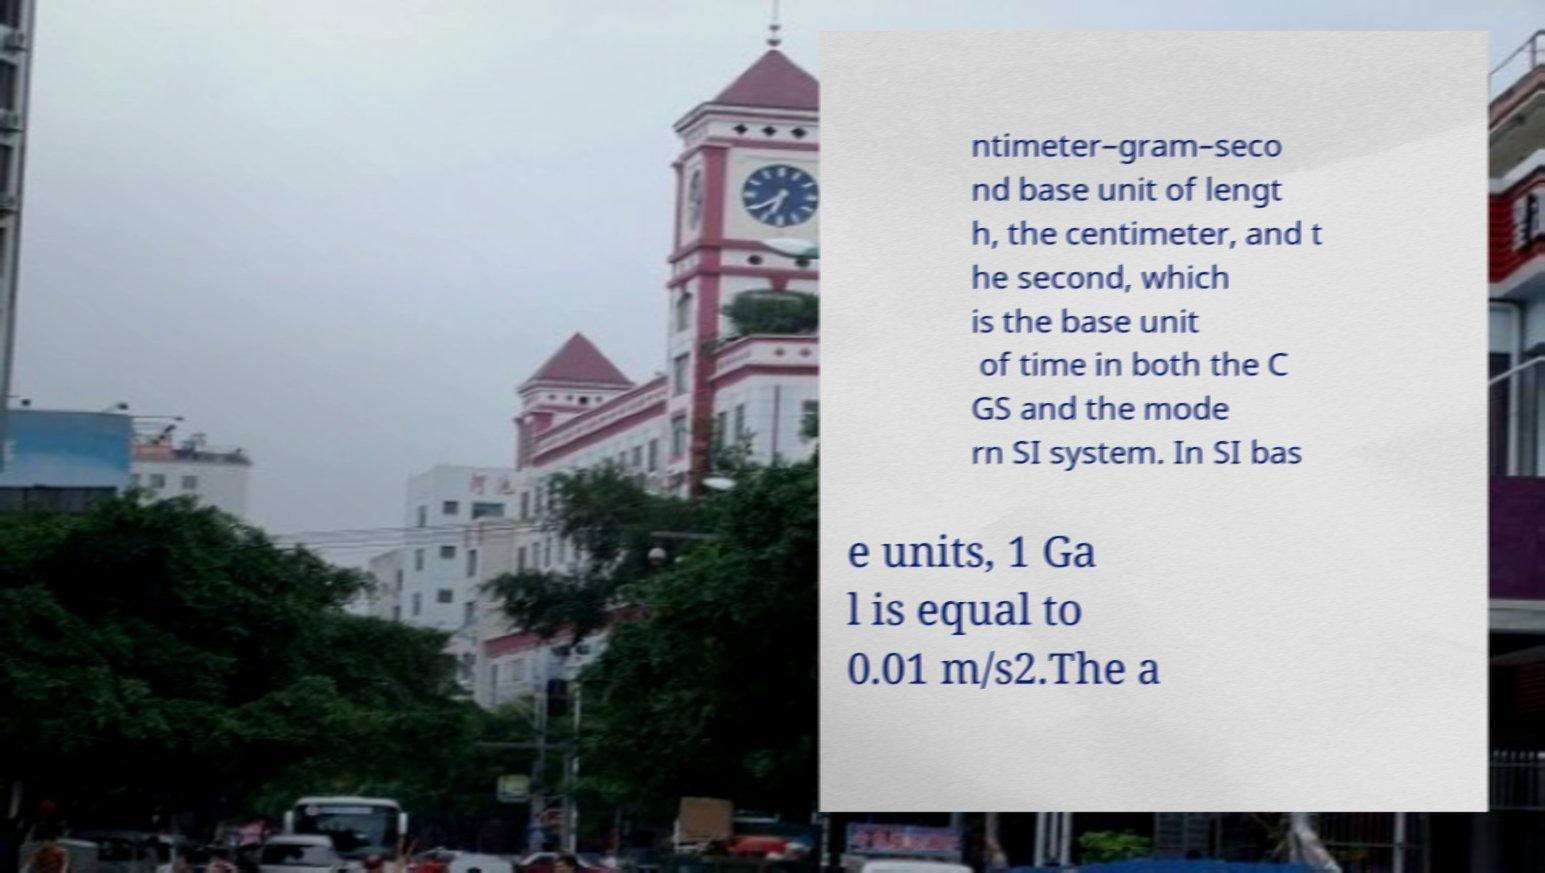Please identify and transcribe the text found in this image. ntimeter–gram–seco nd base unit of lengt h, the centimeter, and t he second, which is the base unit of time in both the C GS and the mode rn SI system. In SI bas e units, 1 Ga l is equal to 0.01 m/s2.The a 